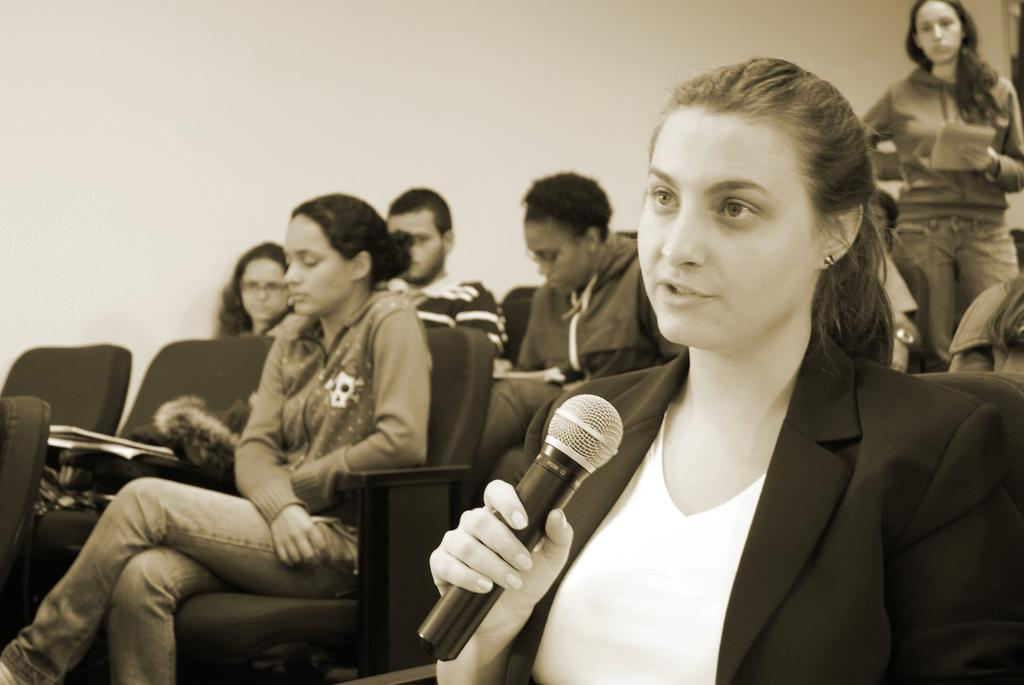What are the majority of people in the image doing? Most of the persons are sitting on chairs. Can you describe the person holding a mic? There is a person in a black suit holding a mic. What is the woman standing near the chairs doing? There is a woman standing and holding a paper. What can be seen on the chairs in the image? There are things on the chairs. Reasoning: Let's think step by step by step in order to produce the conversation. We start by identifying the main activity of the people in the image, which is sitting on chairs. Then, we describe the person holding a mic and the woman standing with a paper, as they are notable figures in the image. Finally, we mention the presence of things on the chairs, which adds more detail to the scene. Absurd Question/Answer: What type of trees can be seen in the background of the scene? There is no background or scene visible in the image, as it focuses on the people sitting on chairs and the individuals holding a mic and a paper. What type of coach is present in the image? There is no coach present in the image; it focuses on the people sitting on chairs and the individuals holding a mic and a paper. 